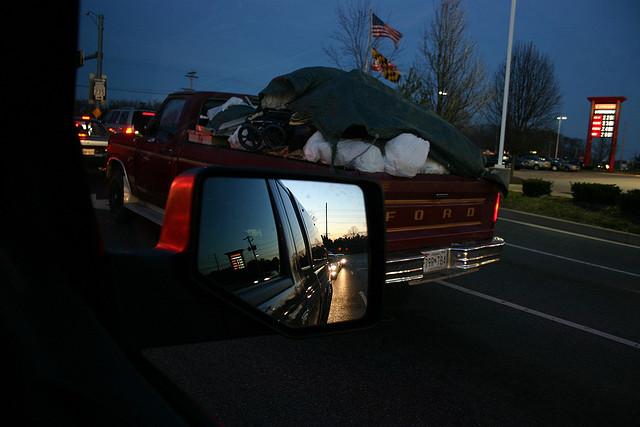What brand of truck is shown?
Quick response, please. Ford. What color is the truck?
Quick response, please. Red. Is there a reflection in the image?
Give a very brief answer. Yes. 